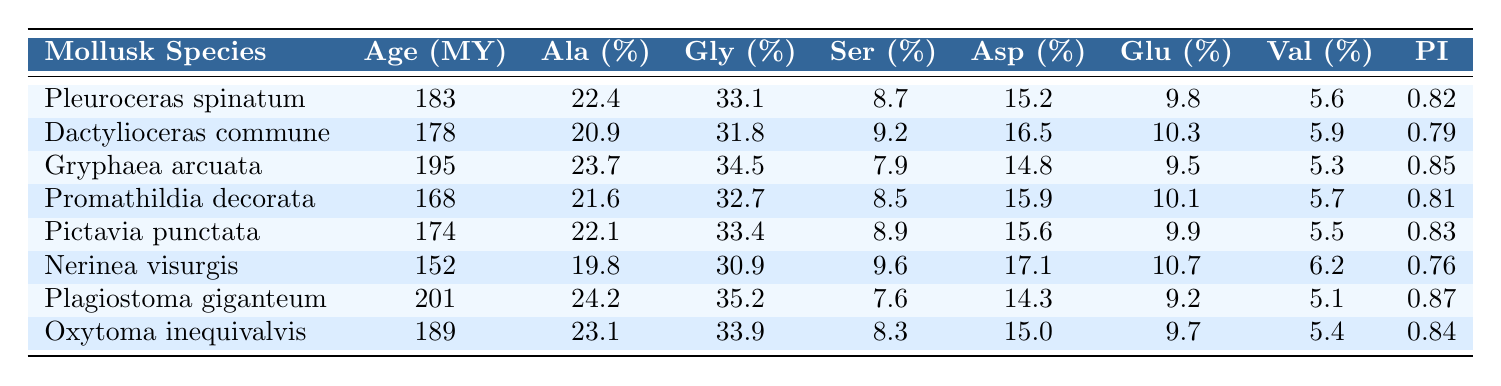What is the preservation index of Gryphaea arcuata? The preservation index for Gryphaea arcuata is listed in the table under the "Preservation Index" column, which shows the value as 0.85.
Answer: 0.85 Which species has the highest percentage of Alanine? By examining the "Alanine (%)" column, we find that Plagiostoma giganteum has the highest value of 24.2%.
Answer: Plagiostoma giganteum What is the difference in Glycine percentage between Pleuroceras spinatum and Dactylioceras commune? The Glycine percentage for Pleuroceras spinatum is 33.1% and for Dactylioceras commune it is 31.8%. The difference is calculated as 33.1% - 31.8% = 1.3%.
Answer: 1.3% Which species has the lowest preservation index? By checking the "Preservation Index" column, Nerinea visurgis has the lowest value of 0.76.
Answer: Nerinea visurgis What is the average value of Serine across all species listed? To find the average Serine percentage, we add all the values: (8.7 + 9.2 + 7.9 + 8.5 + 8.9 + 9.6 + 7.6 + 8.3) = 70.1 and then divide by the number of species, which is 8. The average is 70.1 / 8 ≈ 8.775.
Answer: 8.775 Is the Glycine percentage of Promathildia decorata greater than 32%? The Glycine percentage for Promathildia decorata is 32.7%, which is greater than 32%. Therefore, the statement is true.
Answer: Yes Which mollusk shows the highest Aspartic Acid percentage? The Aspartic Acid percentages for all species are compared and Gryphaea arcuata shows the highest value of 14.8%.
Answer: Gryphaea arcuata If we consider the species with the highest Valine percentage, what is that percentage? By reviewing the "Valine (%)" column, the highest percentage is found in Nerinea visurgis with a value of 6.2%.
Answer: 6.2% Which species are older than 180 million years? From the "Age (Million Years)" column, the species that are older than 180 million years are Pleuroceras spinatum (183), Gryphaea arcuata (195), Plagiostoma giganteum (201), and Oxytoma inequivalvis (189).
Answer: Pleuroceras spinatum, Gryphaea arcuata, Plagiostoma giganteum, Oxytoma inequivalvis What is the sum of Aspartic Acid percentages for all species except Nerinea visurgis? The Aspartic Acid percentages for the species excluding Nerinea visurgis are: 15.2, 16.5, 14.8, 15.9, 15.6, 14.3, 15.0. Adding these gives 15.2 + 16.5 + 14.8 + 15.9 + 15.6 + 14.3 + 15.0 = 107.3.
Answer: 107.3 Which two species have the closest Glycine percentages? Comparing the Glycine percentages, Dactylioceras commune (31.8%) and Nerinea visurgis (30.9%) are the closest, with a difference of 0.9%.
Answer: Dactylioceras commune and Nerinea visurgis 